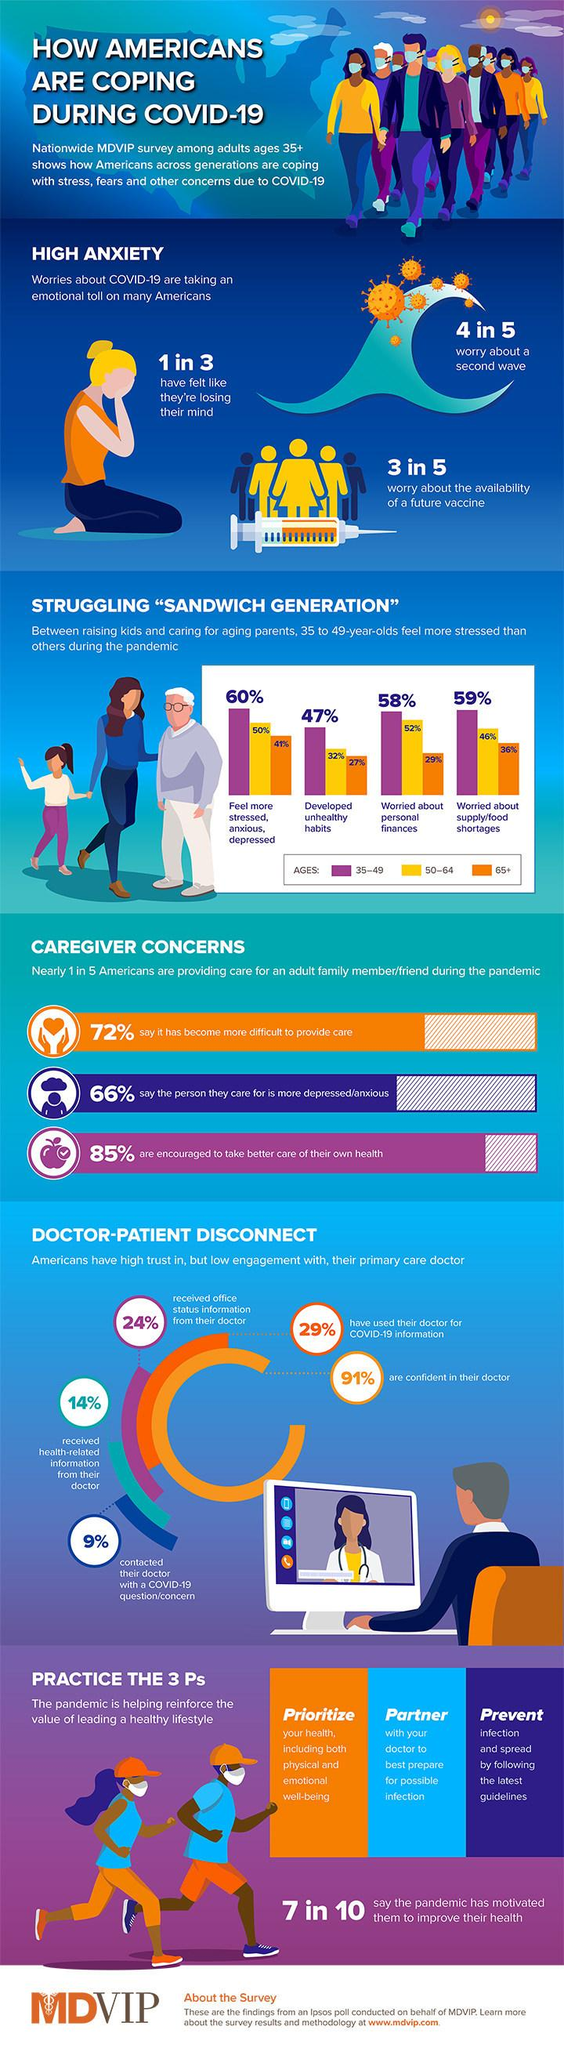Highlight a few significant elements in this photo. According to the MDVIP survey, 52% of Americans aged 50-64 years old were worried about their personal finances during the COVID-19 pandemic. According to the MDVIP survey, 9% of patients in America are not confident about their doctor during the COVID-19 pandemic. According to the MDVIP survey, 14% of patients in America received health-related information from their doctor during the COVID-19 pandemic. According to the MDVIP survey, 29% of Americans aged 65 and older were worried about their personal finances during the COVID-19 pandemic. The MDVIP survey revealed that 59% of Americans aged 35-49 years old were worried about food shortages during the COVID-19 pandemic. 